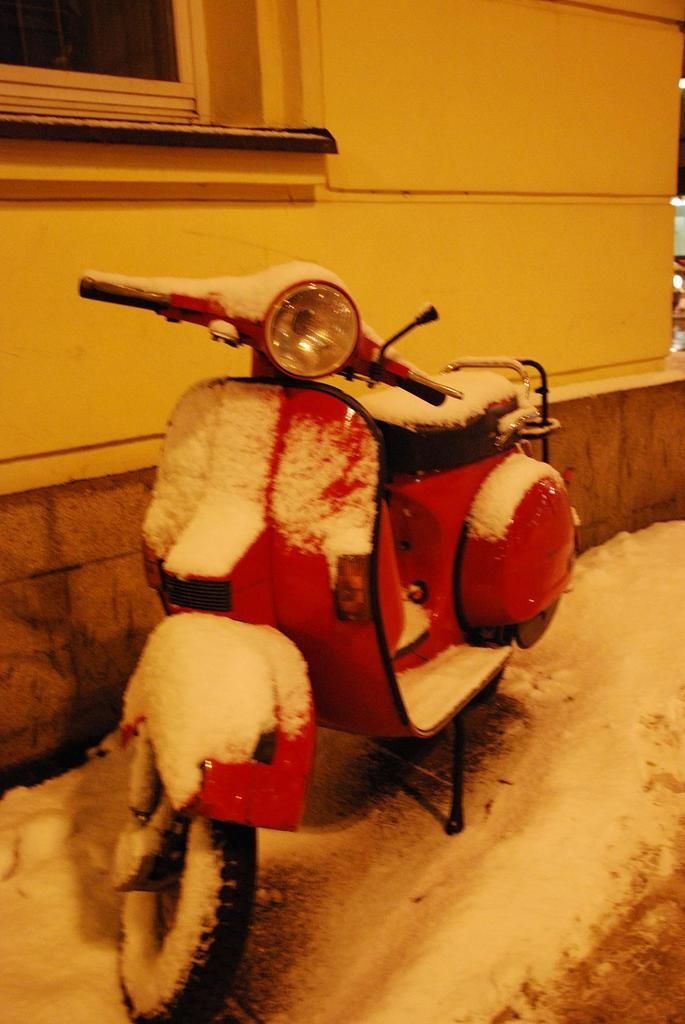What is the main object in the picture? There is a scooter in the picture. How is the scooter affected by the weather? The scooter is covered with snow. What can be seen in the distance in the picture? There is a building in the background of the picture. Is there any indication of an indoor space in the picture? There is a window visible in the picture, but it does not show an indoor space. How many covers are on the scooter in the image? There is no mention of covers on the scooter in the image; it is simply covered with snow. 